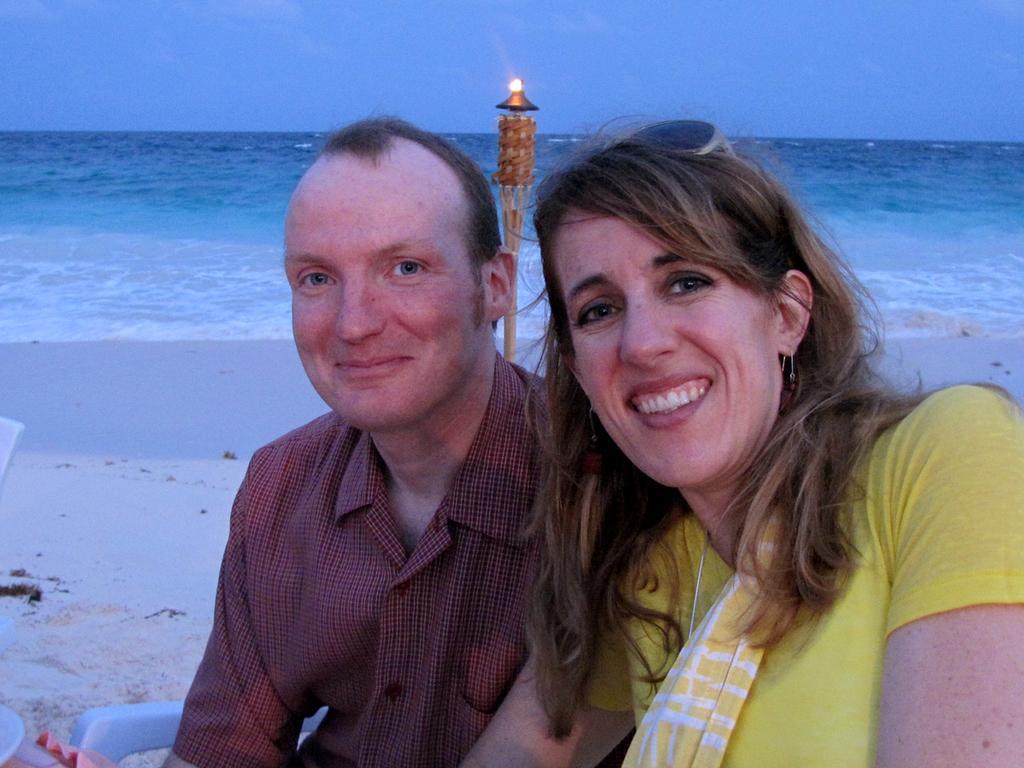How would you summarize this image in a sentence or two? This is the man and woman sitting and smiling. This looks like a seashore. Here is the sea with the water flowing. 